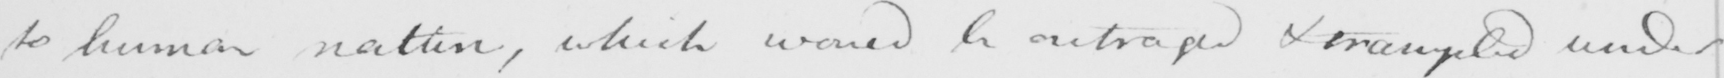What text is written in this handwritten line? to human nature , which would be outraged & trampled under 